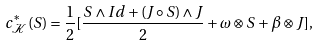<formula> <loc_0><loc_0><loc_500><loc_500>c ^ { * } _ { \mathcal { K } } ( S ) = \frac { 1 } { 2 } [ \frac { S \land I d + ( J \circ S ) \land J } { 2 } + \omega \otimes S + \beta \otimes J ] ,</formula> 